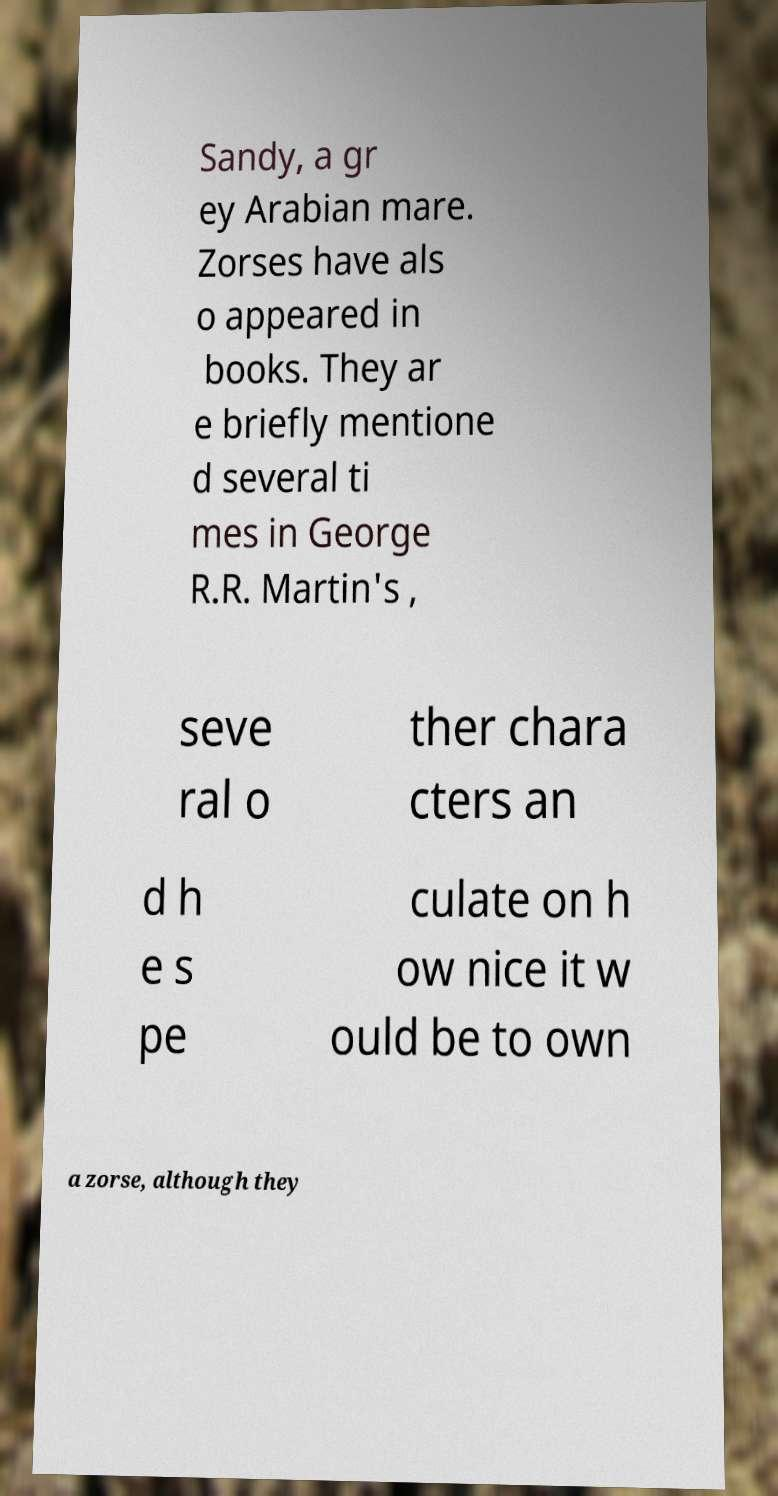Could you extract and type out the text from this image? Sandy, a gr ey Arabian mare. Zorses have als o appeared in books. They ar e briefly mentione d several ti mes in George R.R. Martin's , seve ral o ther chara cters an d h e s pe culate on h ow nice it w ould be to own a zorse, although they 